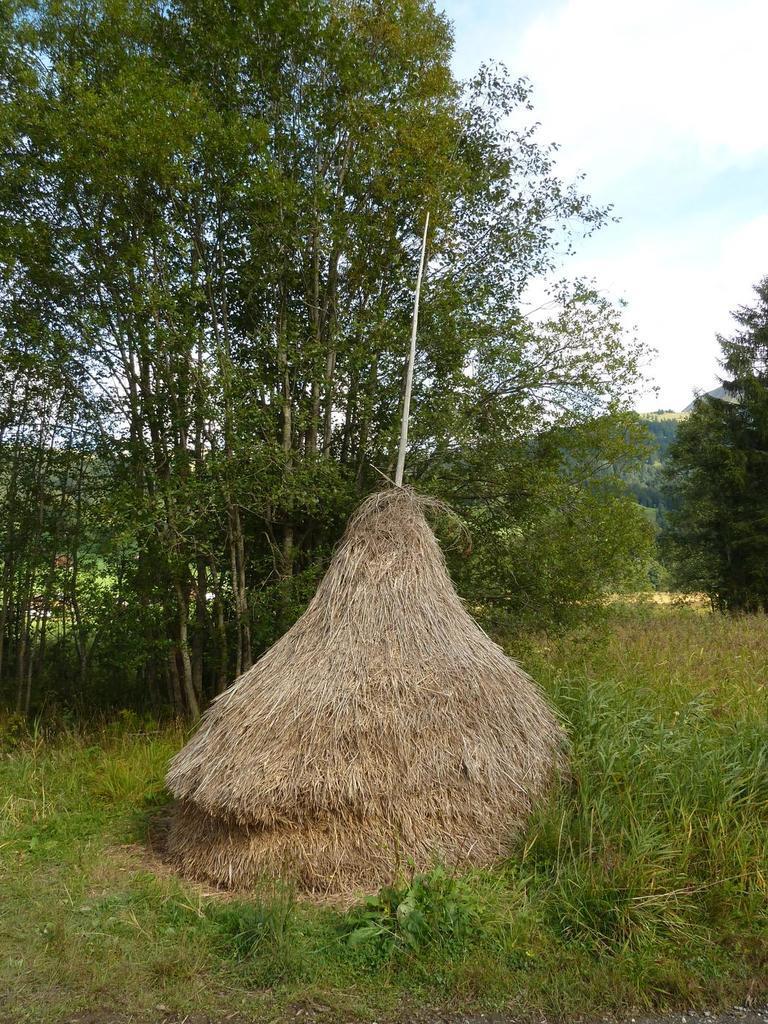Describe this image in one or two sentences. In the picture we can see a grass surface with grass plants on it, we can see a dried grass hut with a pole on it and behind it we can see many trees and sky with clouds. 